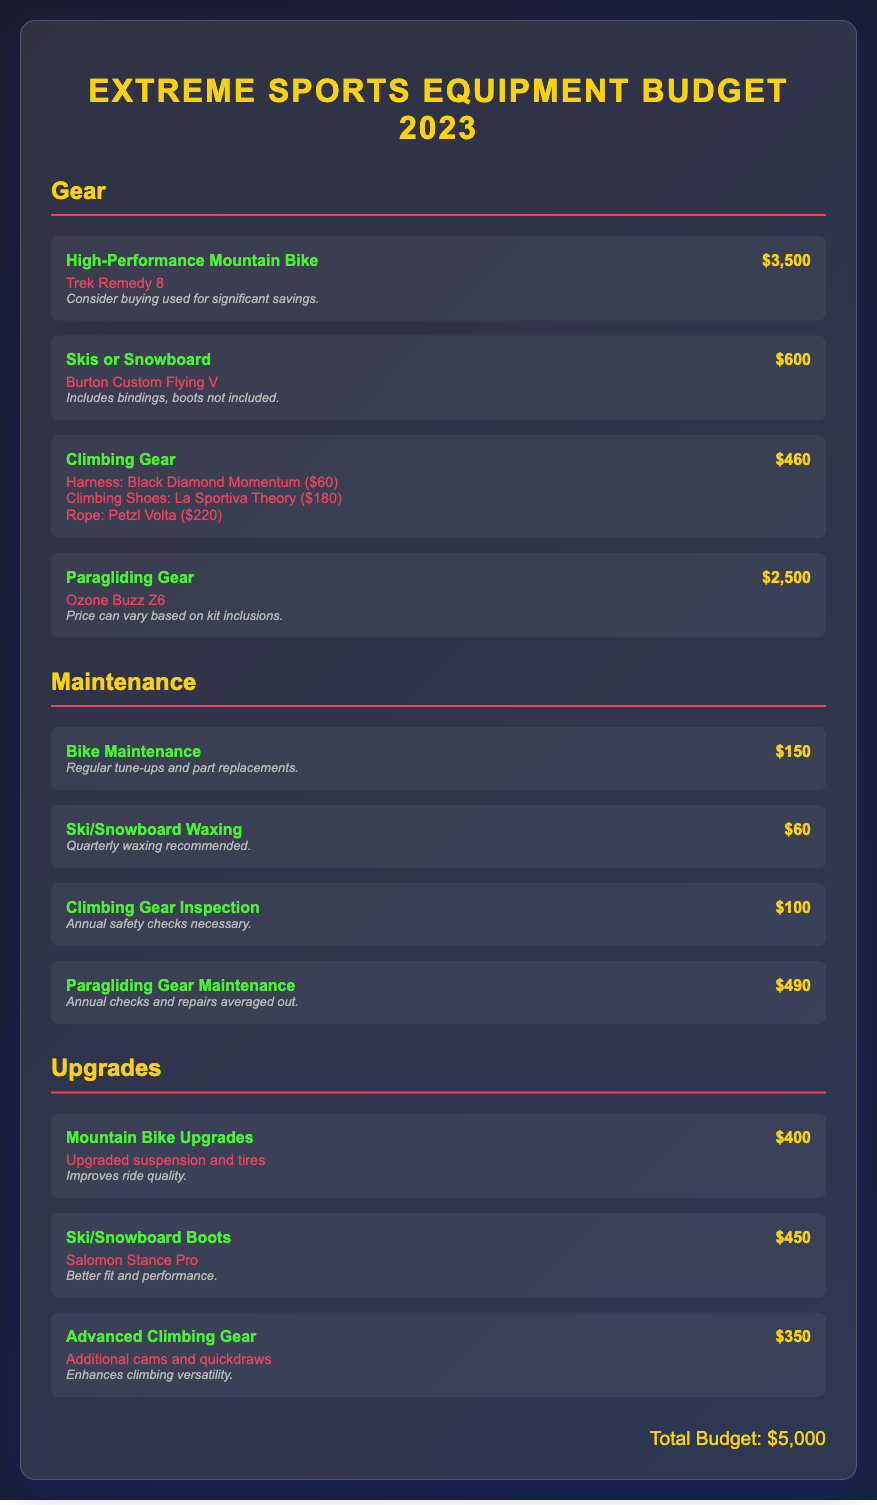what is the total budget? The total budget is summarized at the end of the document, which states "Total Budget: $5,000."
Answer: $5,000 how much does the High-Performance Mountain Bike cost? The cost of the High-Performance Mountain Bike is listed in the gear section as "$3,500."
Answer: $3,500 what is included in the Climbing Gear cost? The Climbing Gear includes specific items with their costs detailed, such as Harness, Climbing Shoes, and Rope.
Answer: Harness, Climbing Shoes, Rope how much do Ski/Snowboard Boots cost? The document specifies the cost of Ski/Snowboard Boots as "$450."
Answer: $450 what is the maintenance cost for Bike Maintenance? The maintenance section lists the cost for Bike Maintenance, which is "$150."
Answer: $150 what is the total cost of Paragliding Gear? The cost of Paragliding Gear is listed in the gear section as "$2,500."
Answer: $2,500 how often should Ski/Snowboard Waxing be done? The document recommends quarterly waxing for ski/snowboard maintenance.
Answer: Quarterly what is the average cost for Paragliding Gear Maintenance? The average cost for Paragliding Gear Maintenance is stated as "$490."
Answer: $490 what types of items are included in Gear? The gear section contains different categories of extreme sports equipment including bikes, skis, climbing gear, and paragliding gear.
Answer: Bikes, Skis, Climbing Gear, Paragliding Gear 